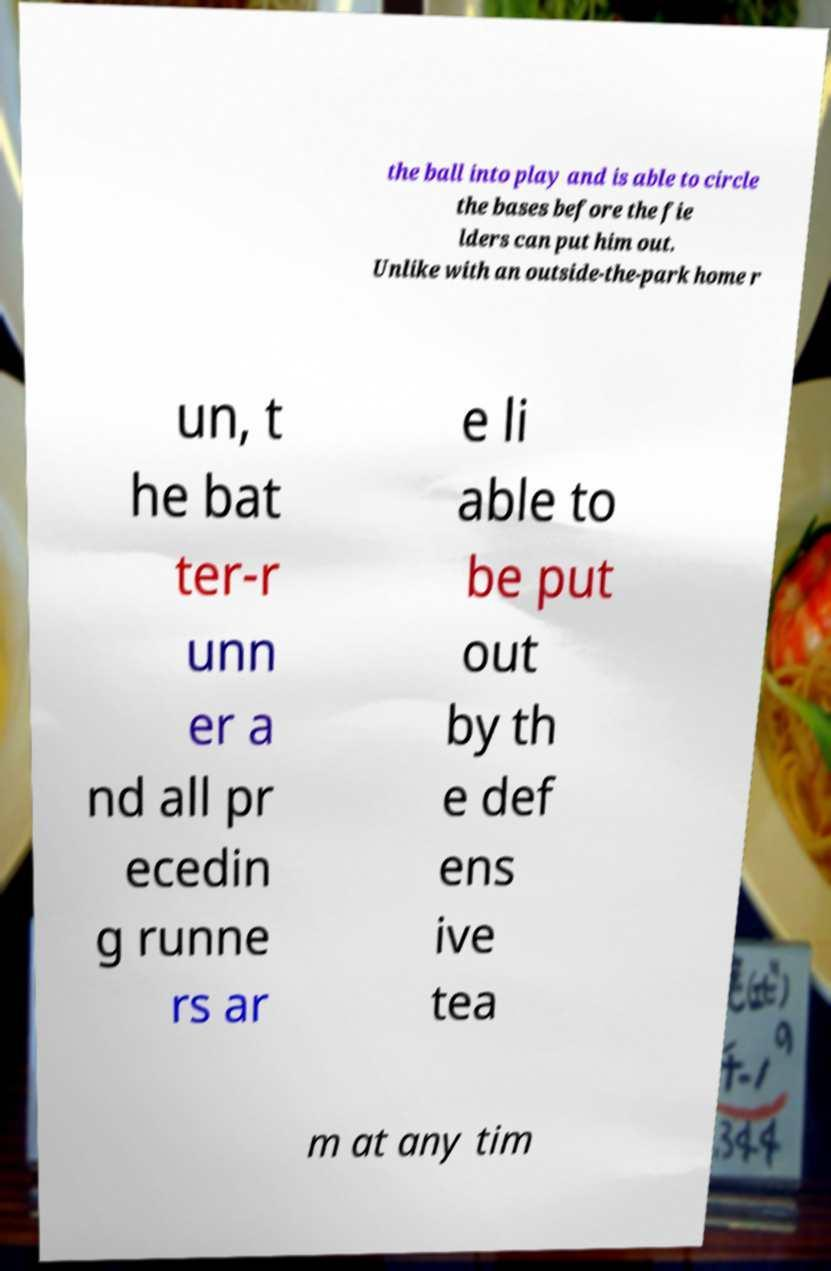Could you extract and type out the text from this image? the ball into play and is able to circle the bases before the fie lders can put him out. Unlike with an outside-the-park home r un, t he bat ter-r unn er a nd all pr ecedin g runne rs ar e li able to be put out by th e def ens ive tea m at any tim 